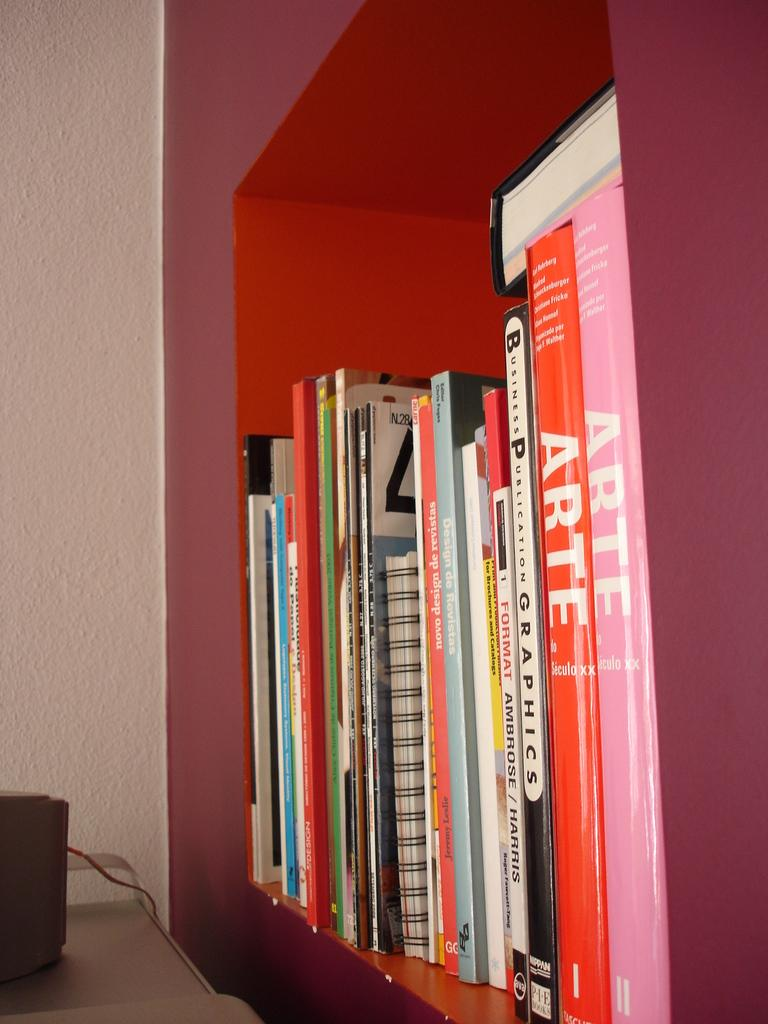<image>
Present a compact description of the photo's key features. Two books called ARTE sit on a shelf with many other books. 